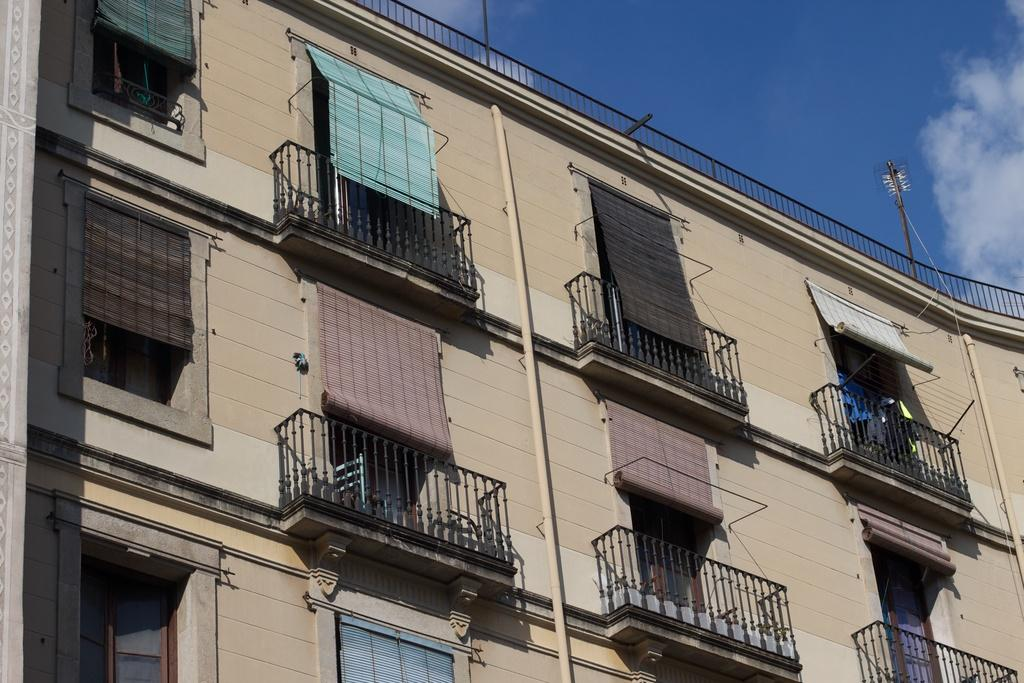What type of structure is depicted in the image? The image is of a building. What architectural features can be seen on the building? There are windows, window blinds, a railing, pipes, and poles visible on the building. What is the condition of the sky in the image? The sky is clear and it is sunny in the image. What type of throat condition can be seen in the image? There is no throat condition present in the image; it is a picture of a building. What scene is depicted in the image? The image depicts a building, not a scene. 